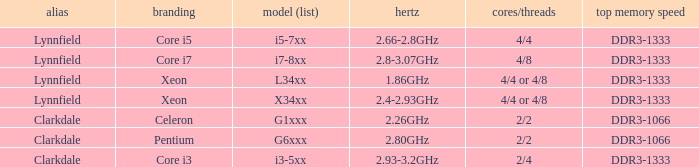What frequency does the Pentium processor use? 2.80GHz. 